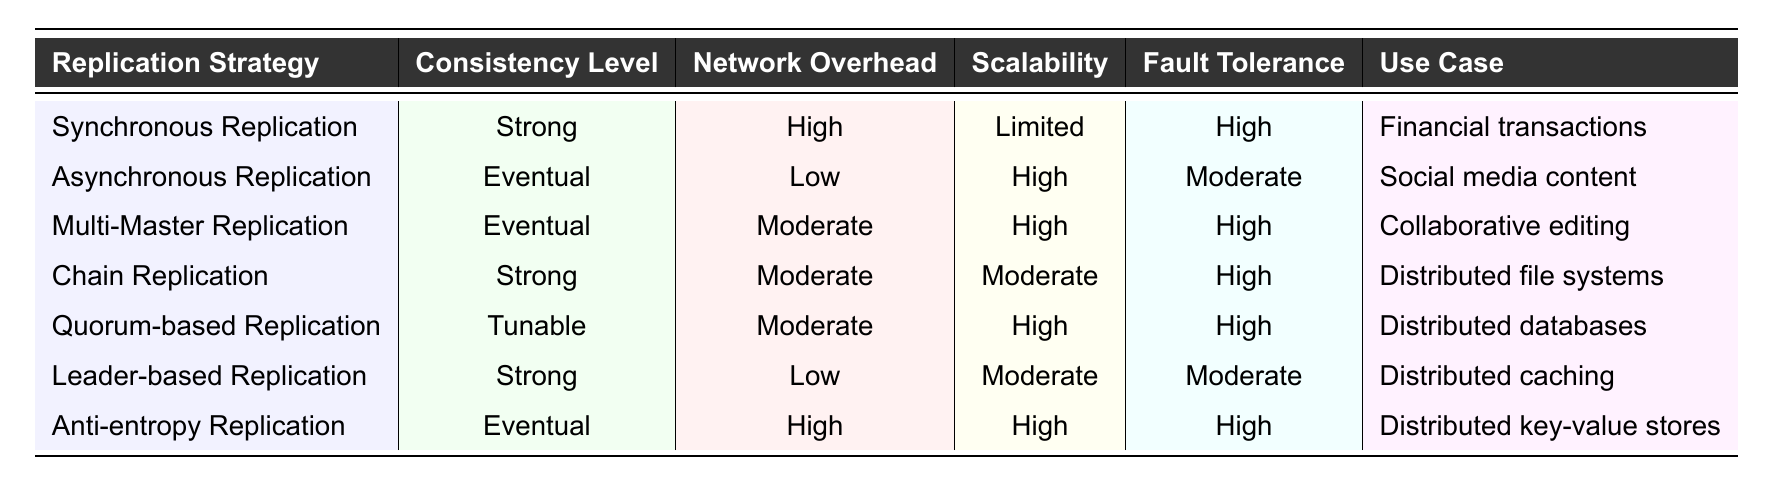What replication strategy has the highest network overhead? By looking at the "Network Overhead" column, the replication strategies are ranked as High, Moderate, and Low. Synchronous Replication and Anti-entropy Replication both have a "High" rating, but because we asked for the highest, we'll consider Synchronous Replication which also provides a strong consistency level.
Answer: Synchronous Replication Which replication strategy is best suited for financial transactions? The "Use Case" column indicates that Synchronous Replication is specifically designed for "Financial transactions," and it has a strong consistency level ensuring data accuracy.
Answer: Synchronous Replication What is the scalability level of Leader-based Replication? The table shows Leader-based Replication's scalability labeled as "Moderate." This categorization is directly obtained from the "Scalability" column.
Answer: Moderate Is there a replication strategy with both high fault tolerance and low network overhead? Examining the "Network Overhead" and "Fault Tolerance" columns, Leader-based Replication has Moderate fault tolerance and Low network overhead, which means it doesn’t meet both conditions for High values. Therefore, the answer is No.
Answer: No Which replication strategy has moderate scalability? Checking the "Scalability" column, we can find Chain Replication and Leader-based Replication categorized as having "Moderate" scalability.
Answer: Chain Replication and Leader-based Replication What is the average network overhead of the replication strategies? The network overhead values are High, Low, Moderate, Moderate, Moderate, Low, and High. Converting these to a numerical scale (High=3, Moderate=2, Low=1): (3+1+2+2+2+1+3) = 14. Dividing by 7 gives an average of 14/7 = 2.
Answer: 2 Does Multi-Master Replication provide strong consistency? Referring to the "Consistency Level" column, Multi-Master Replication is marked as "Eventual," which indicates that it does not provide strong consistency.
Answer: No Which strategy has high fault tolerance but low network overhead? Looking at the "Fault Tolerance" and "Network Overhead" columns, we see that none of the strategies meet both criteria simultaneously as all with high tolerance have either moderate or high overhead.
Answer: None 